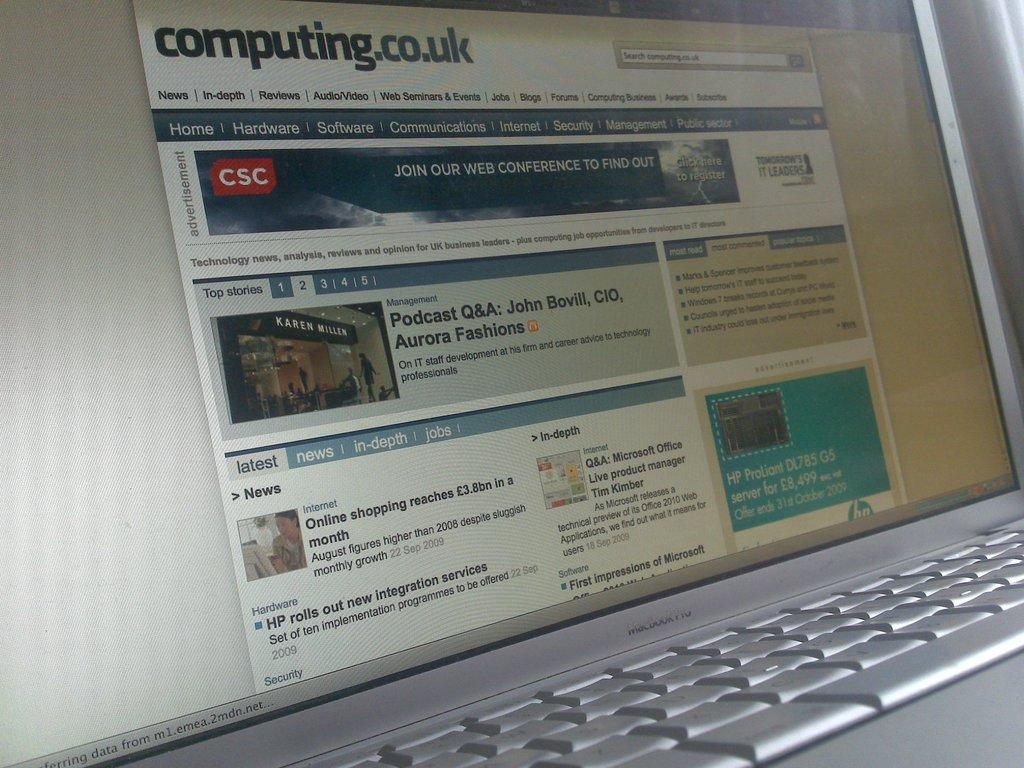<image>
Create a compact narrative representing the image presented. Silver laptop showing a podcast  with John Bovil on the screen. 